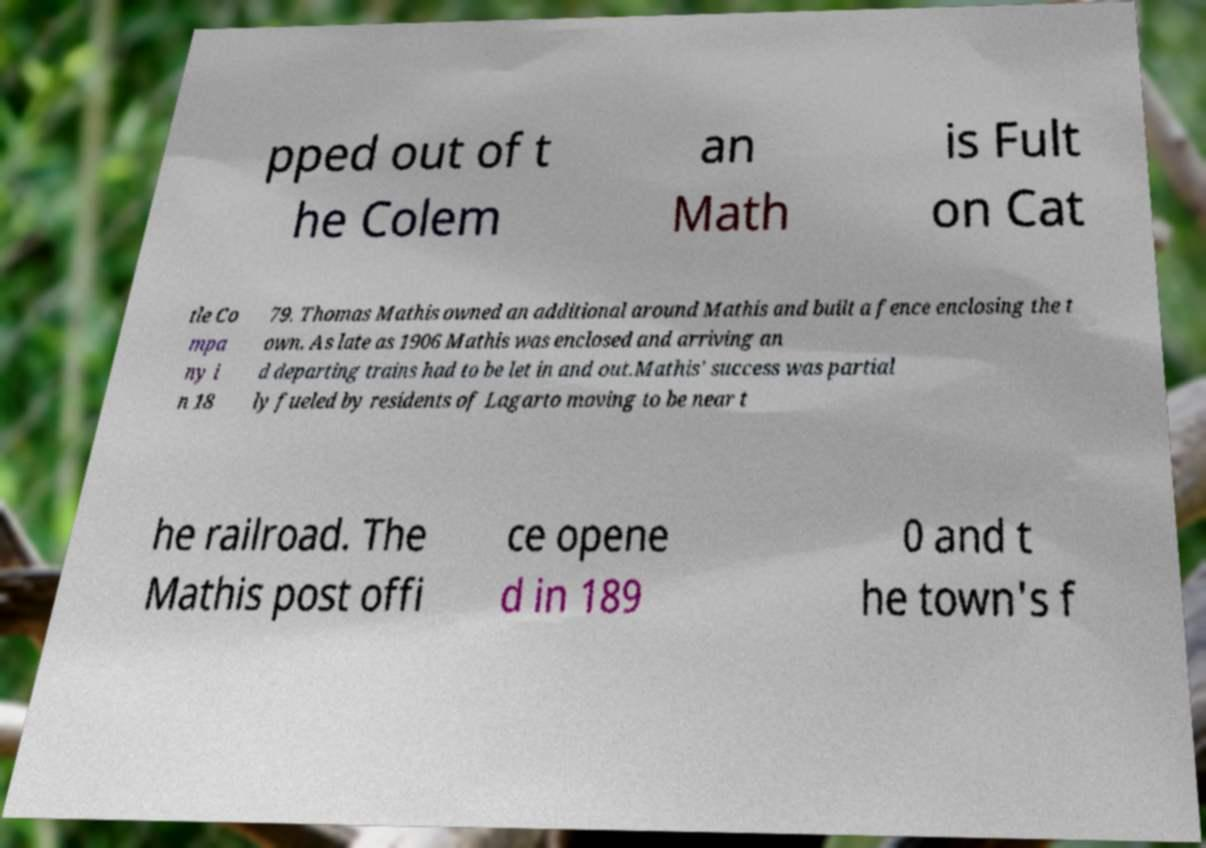What messages or text are displayed in this image? I need them in a readable, typed format. pped out of t he Colem an Math is Fult on Cat tle Co mpa ny i n 18 79. Thomas Mathis owned an additional around Mathis and built a fence enclosing the t own. As late as 1906 Mathis was enclosed and arriving an d departing trains had to be let in and out.Mathis' success was partial ly fueled by residents of Lagarto moving to be near t he railroad. The Mathis post offi ce opene d in 189 0 and t he town's f 